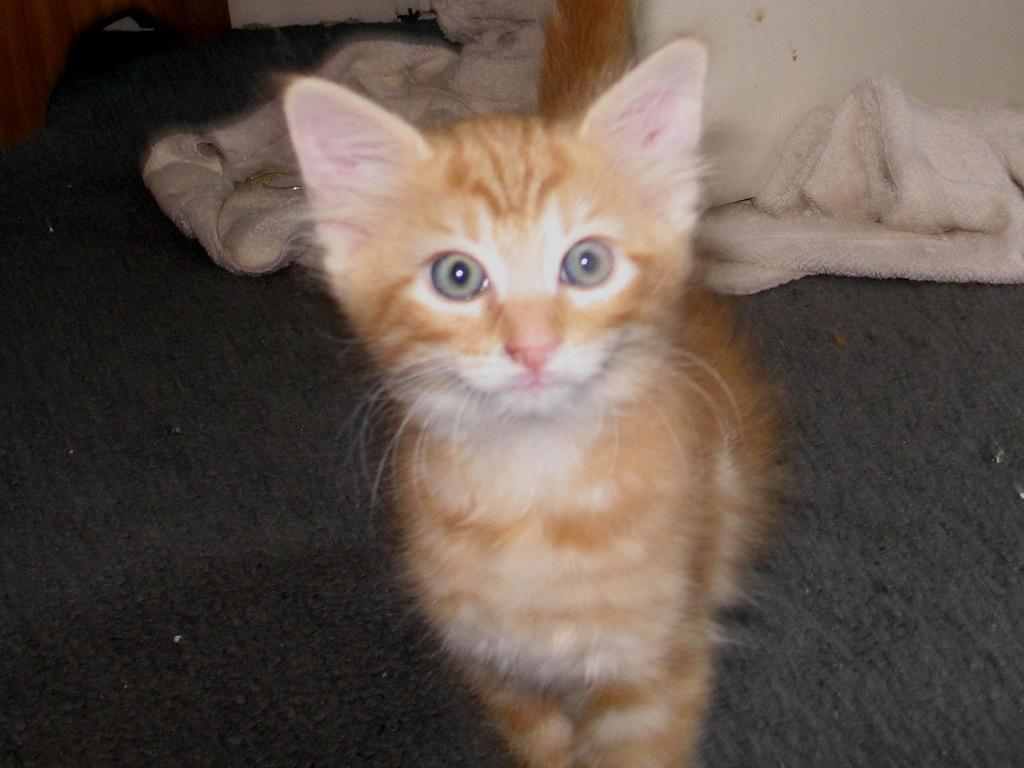What type of animal is in the image? There is a cat in the image. What color is the cat? The cat is brown in color. What other object is in the image besides the cat? There is a cloth in the image. What color is the cloth? The cloth is white in color. How many ornaments does the boy have on his nails in the image? There is no boy or nails present in the image. What type of creature is shown interacting with the cat on the cloth? There is no creature shown interacting with the cat on the cloth; only the cat and the cloth are present. 